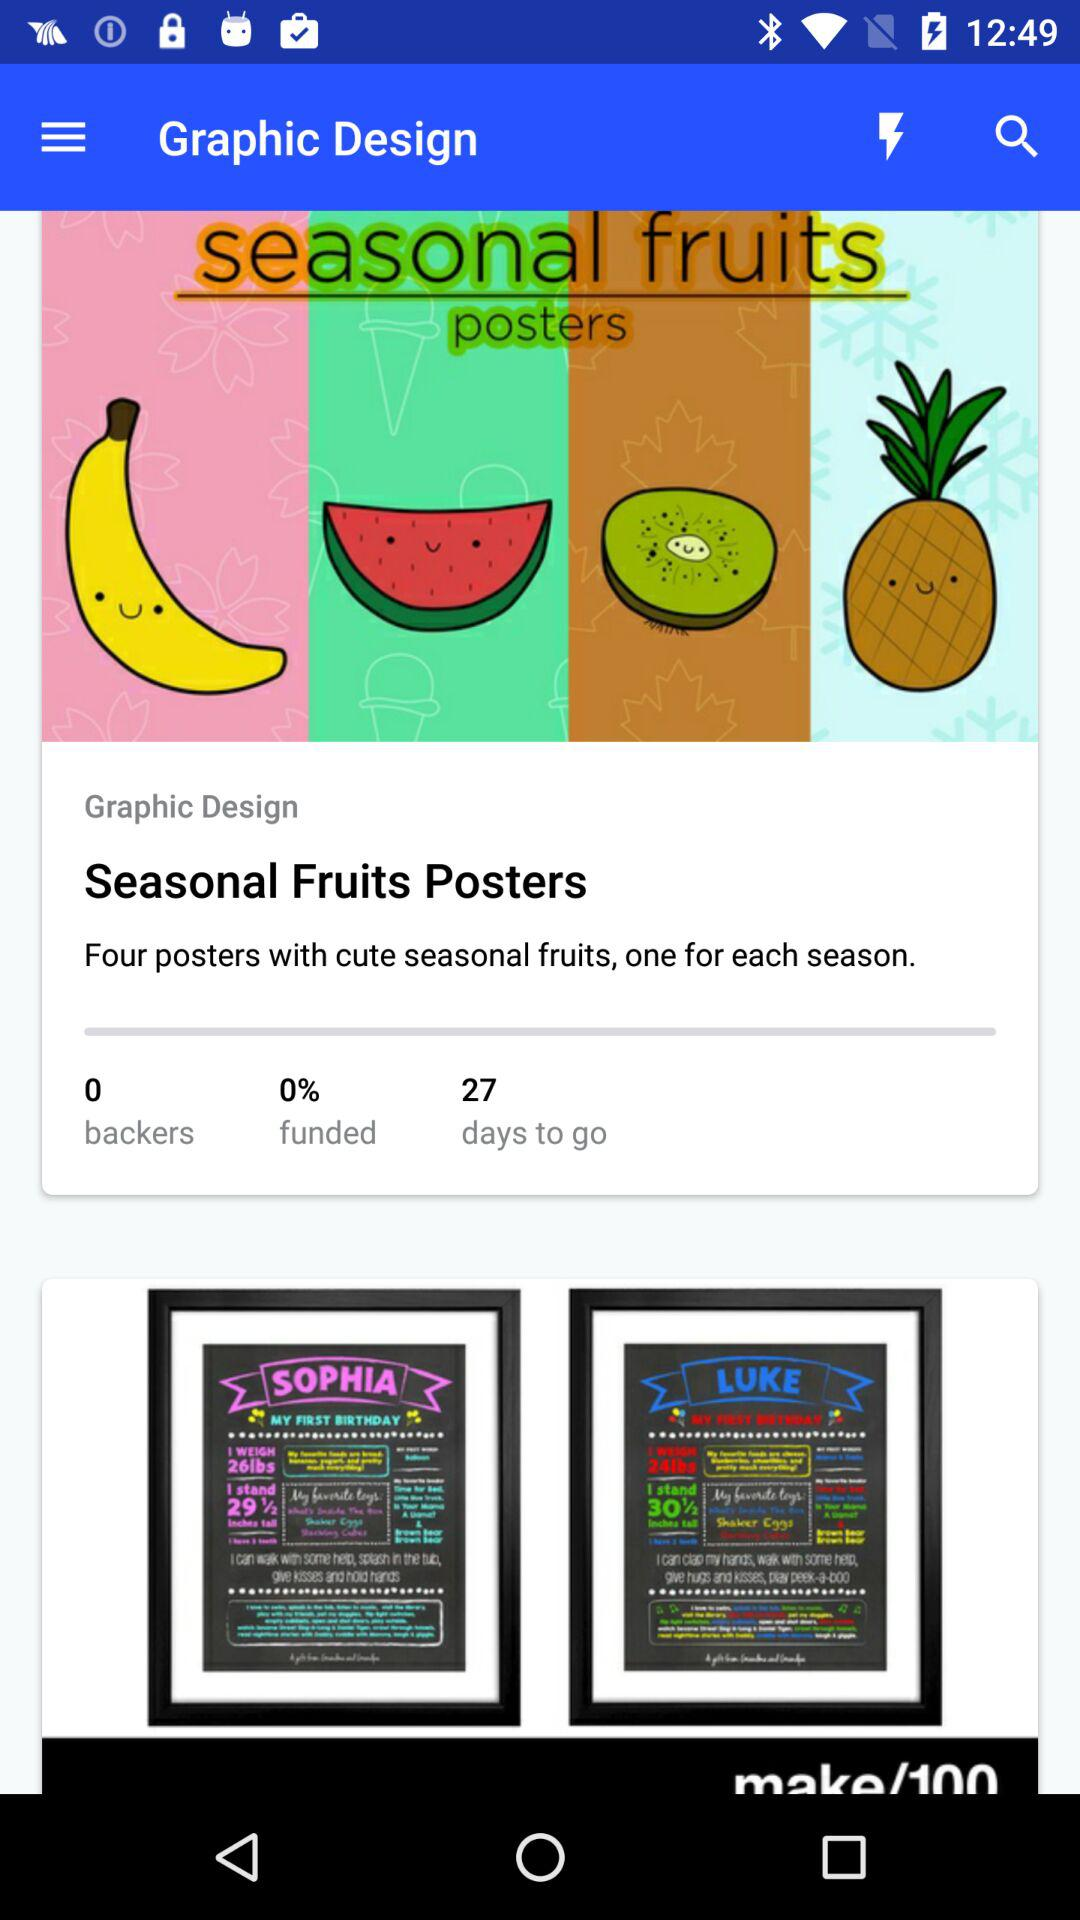How many percent funded is the project?
Answer the question using a single word or phrase. 0% 